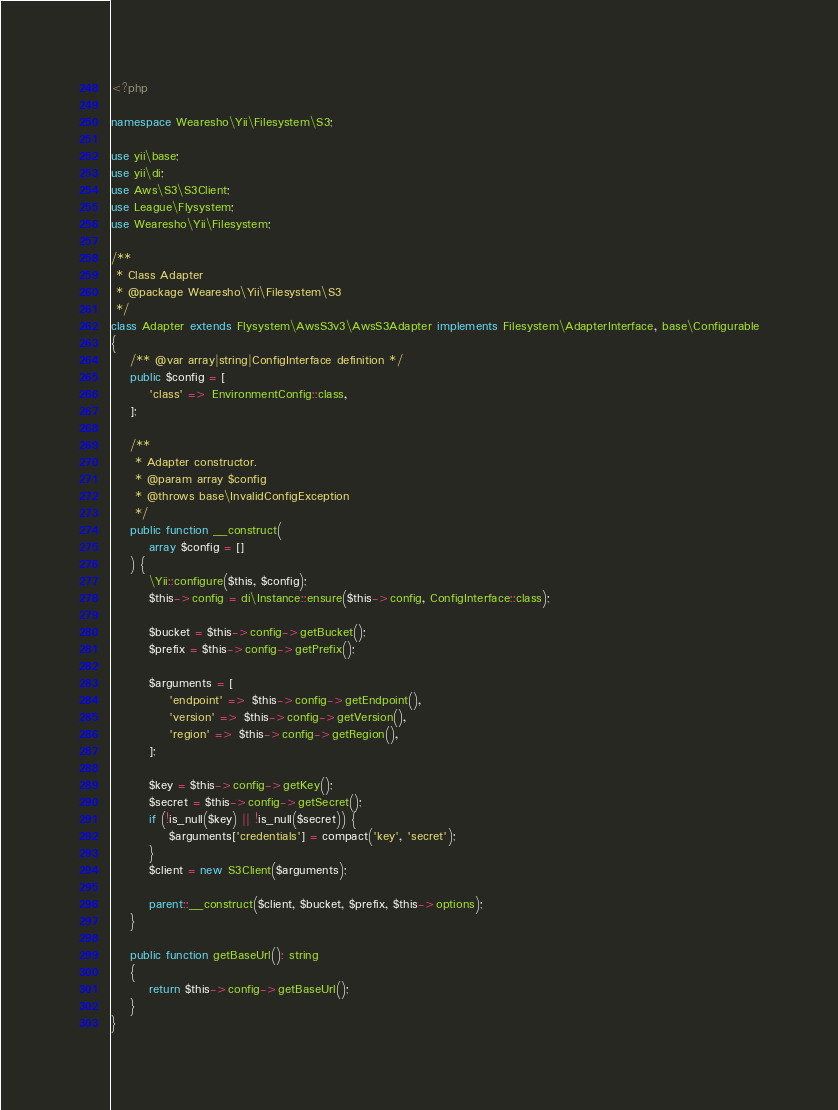<code> <loc_0><loc_0><loc_500><loc_500><_PHP_><?php

namespace Wearesho\Yii\Filesystem\S3;

use yii\base;
use yii\di;
use Aws\S3\S3Client;
use League\Flysystem;
use Wearesho\Yii\Filesystem;

/**
 * Class Adapter
 * @package Wearesho\Yii\Filesystem\S3
 */
class Adapter extends Flysystem\AwsS3v3\AwsS3Adapter implements Filesystem\AdapterInterface, base\Configurable
{
    /** @var array|string|ConfigInterface definition */
    public $config = [
        'class' => EnvironmentConfig::class,
    ];

    /**
     * Adapter constructor.
     * @param array $config
     * @throws base\InvalidConfigException
     */
    public function __construct(
        array $config = []
    ) {
        \Yii::configure($this, $config);
        $this->config = di\Instance::ensure($this->config, ConfigInterface::class);

        $bucket = $this->config->getBucket();
        $prefix = $this->config->getPrefix();

        $arguments = [
            'endpoint' => $this->config->getEndpoint(),
            'version' => $this->config->getVersion(),
            'region' => $this->config->getRegion(),
        ];

        $key = $this->config->getKey();
        $secret = $this->config->getSecret();
        if (!is_null($key) || !is_null($secret)) {
            $arguments['credentials'] = compact('key', 'secret');
        }
        $client = new S3Client($arguments);

        parent::__construct($client, $bucket, $prefix, $this->options);
    }

    public function getBaseUrl(): string
    {
        return $this->config->getBaseUrl();
    }
}
</code> 